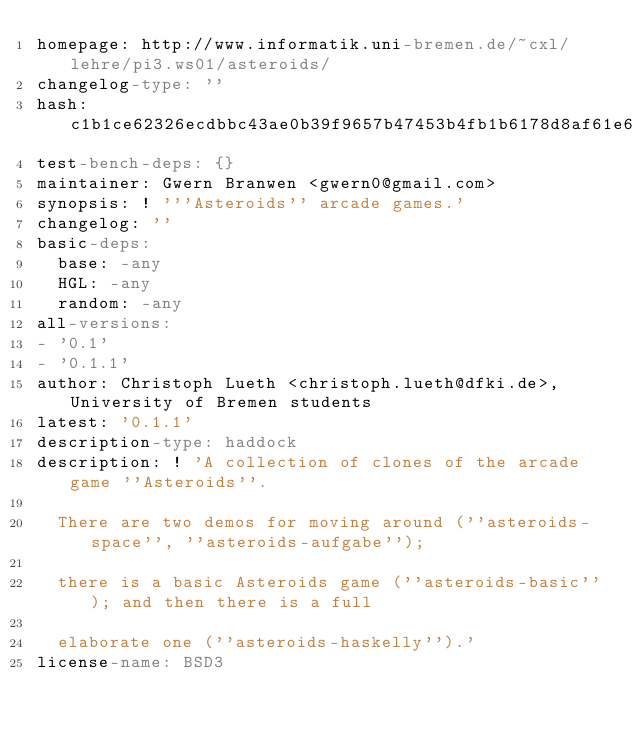Convert code to text. <code><loc_0><loc_0><loc_500><loc_500><_YAML_>homepage: http://www.informatik.uni-bremen.de/~cxl/lehre/pi3.ws01/asteroids/
changelog-type: ''
hash: c1b1ce62326ecdbbc43ae0b39f9657b47453b4fb1b6178d8af61e660d63dc1ce
test-bench-deps: {}
maintainer: Gwern Branwen <gwern0@gmail.com>
synopsis: ! '''Asteroids'' arcade games.'
changelog: ''
basic-deps:
  base: -any
  HGL: -any
  random: -any
all-versions:
- '0.1'
- '0.1.1'
author: Christoph Lueth <christoph.lueth@dfki.de>, University of Bremen students
latest: '0.1.1'
description-type: haddock
description: ! 'A collection of clones of the arcade game ''Asteroids''.

  There are two demos for moving around (''asteroids-space'', ''asteroids-aufgabe'');

  there is a basic Asteroids game (''asteroids-basic''); and then there is a full

  elaborate one (''asteroids-haskelly'').'
license-name: BSD3
</code> 